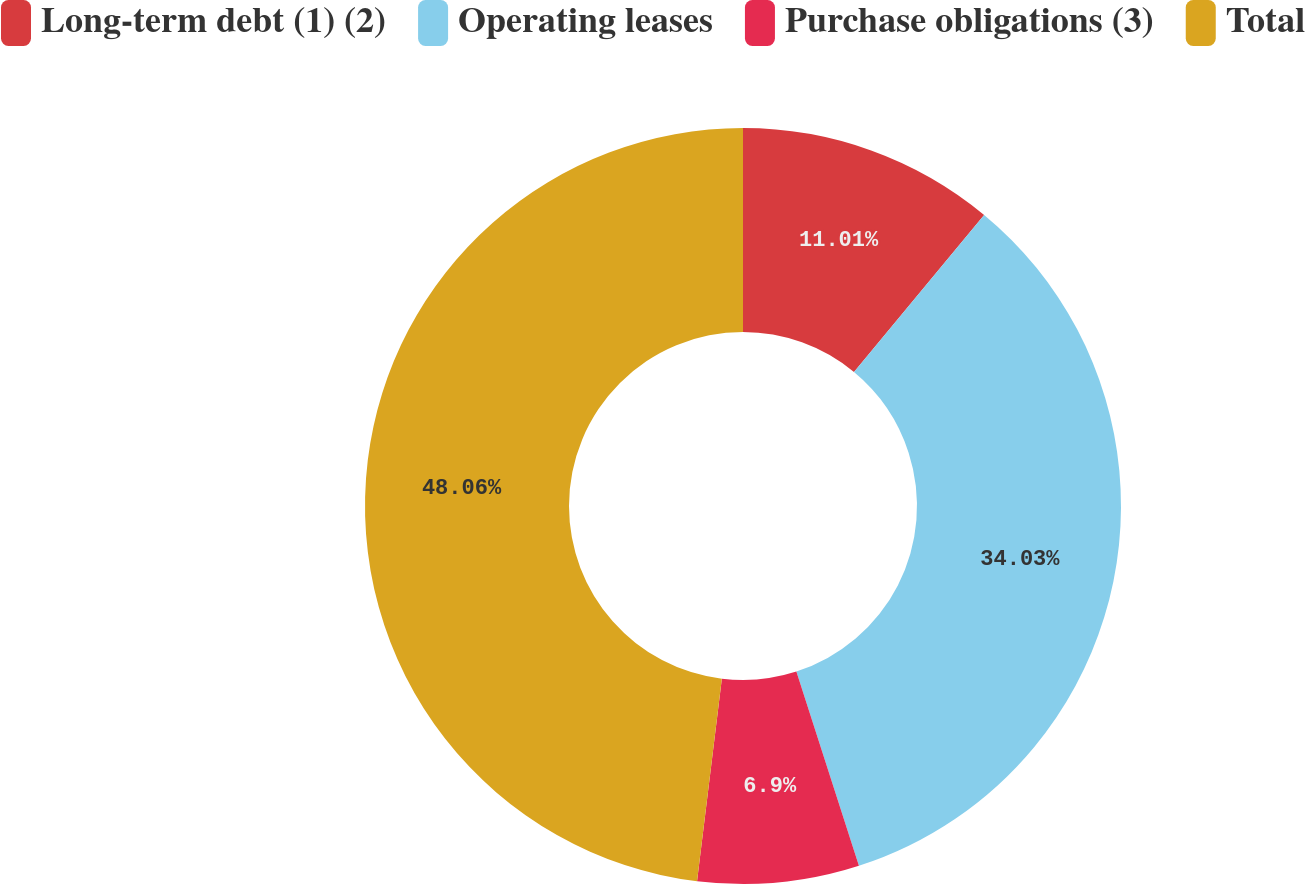Convert chart. <chart><loc_0><loc_0><loc_500><loc_500><pie_chart><fcel>Long-term debt (1) (2)<fcel>Operating leases<fcel>Purchase obligations (3)<fcel>Total<nl><fcel>11.01%<fcel>34.03%<fcel>6.9%<fcel>48.06%<nl></chart> 